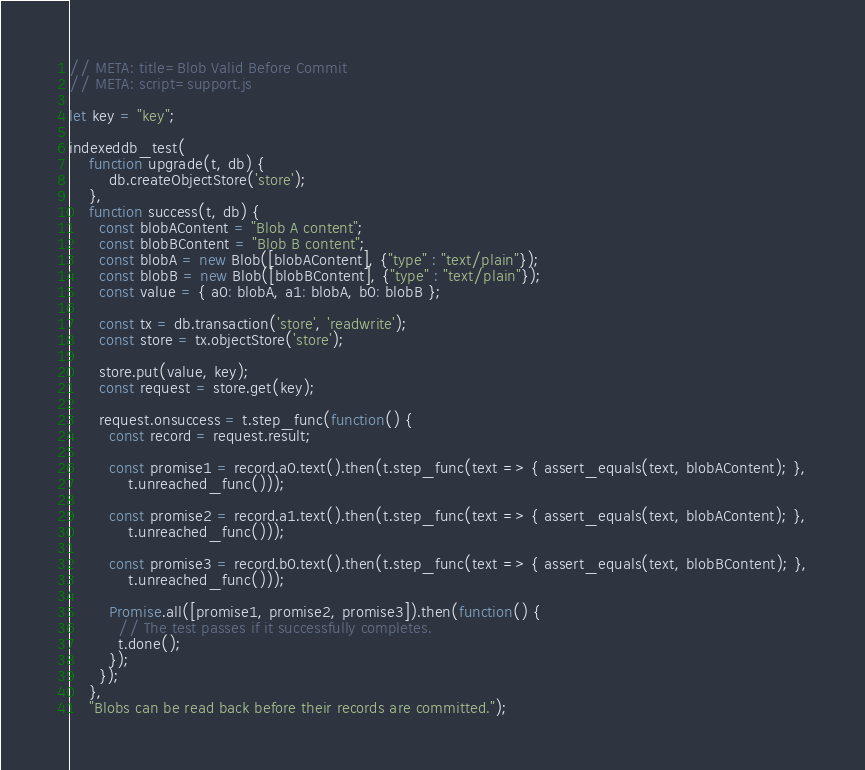<code> <loc_0><loc_0><loc_500><loc_500><_JavaScript_>// META: title=Blob Valid Before Commit
// META: script=support.js

let key = "key";

indexeddb_test(
    function upgrade(t, db) {
        db.createObjectStore('store');
    },
    function success(t, db) {
      const blobAContent = "Blob A content";
      const blobBContent = "Blob B content";
      const blobA = new Blob([blobAContent], {"type" : "text/plain"});
      const blobB = new Blob([blobBContent], {"type" : "text/plain"});
      const value = { a0: blobA, a1: blobA, b0: blobB };

      const tx = db.transaction('store', 'readwrite');
      const store = tx.objectStore('store');

      store.put(value, key);
      const request = store.get(key);

      request.onsuccess = t.step_func(function() {
        const record = request.result;

        const promise1 = record.a0.text().then(t.step_func(text => { assert_equals(text, blobAContent); },
            t.unreached_func()));

        const promise2 = record.a1.text().then(t.step_func(text => { assert_equals(text, blobAContent); },
            t.unreached_func()));

        const promise3 = record.b0.text().then(t.step_func(text => { assert_equals(text, blobBContent); },
            t.unreached_func()));

        Promise.all([promise1, promise2, promise3]).then(function() {
          // The test passes if it successfully completes.
          t.done();
        });
      });
    },
    "Blobs can be read back before their records are committed.");</code> 